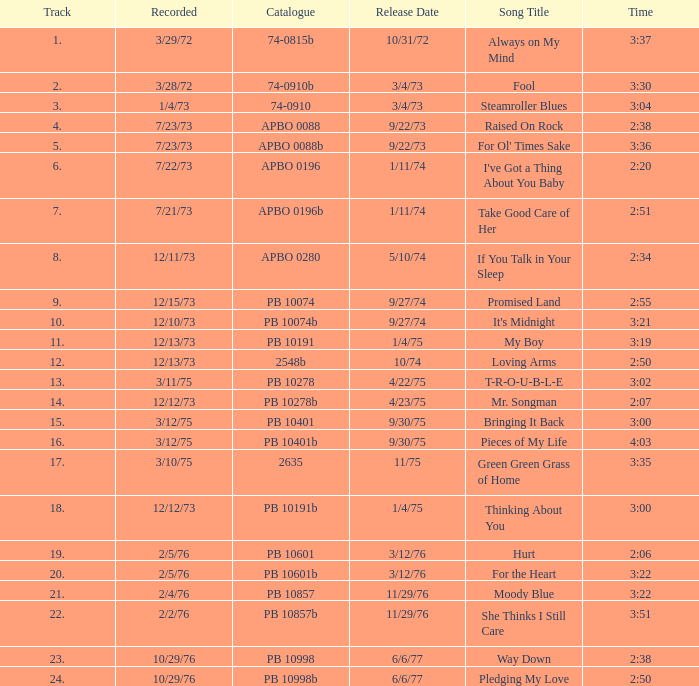Can you provide the release date record for october 29, 1976, and a 2:50 time? 6/6/77. 